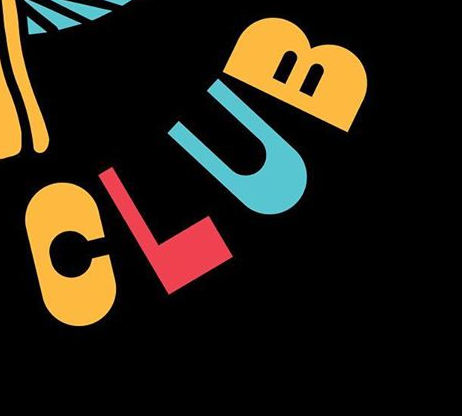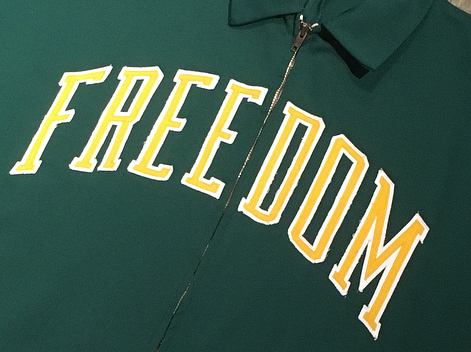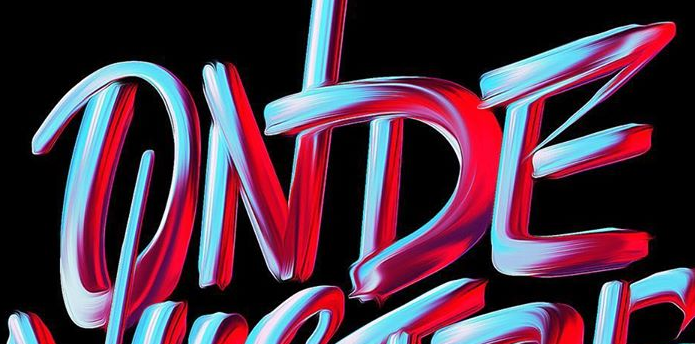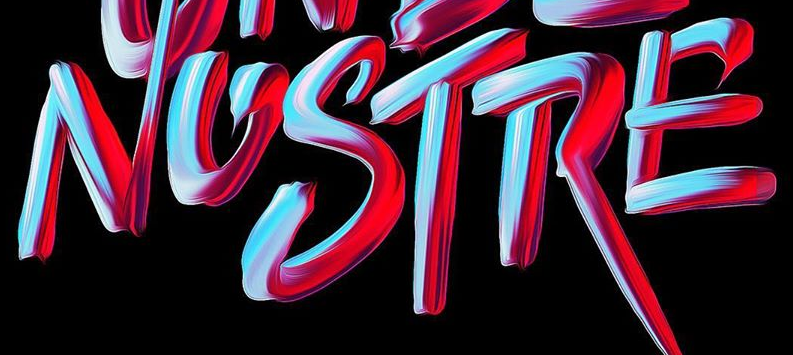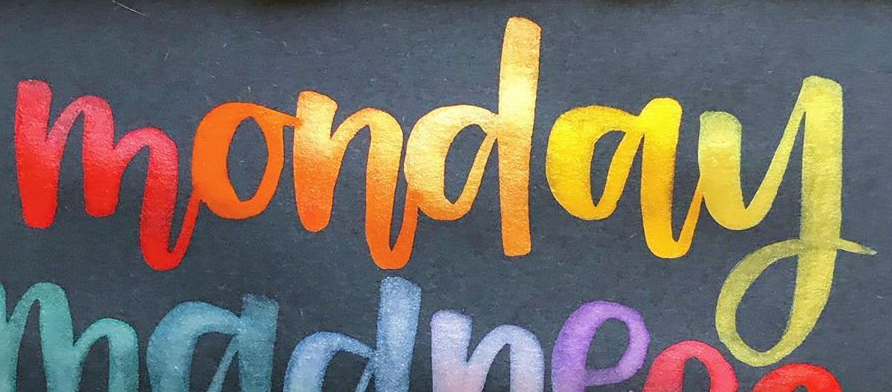What text is displayed in these images sequentially, separated by a semicolon? CLUB; FREEDOM; ONDE; NOSTRE; monday 